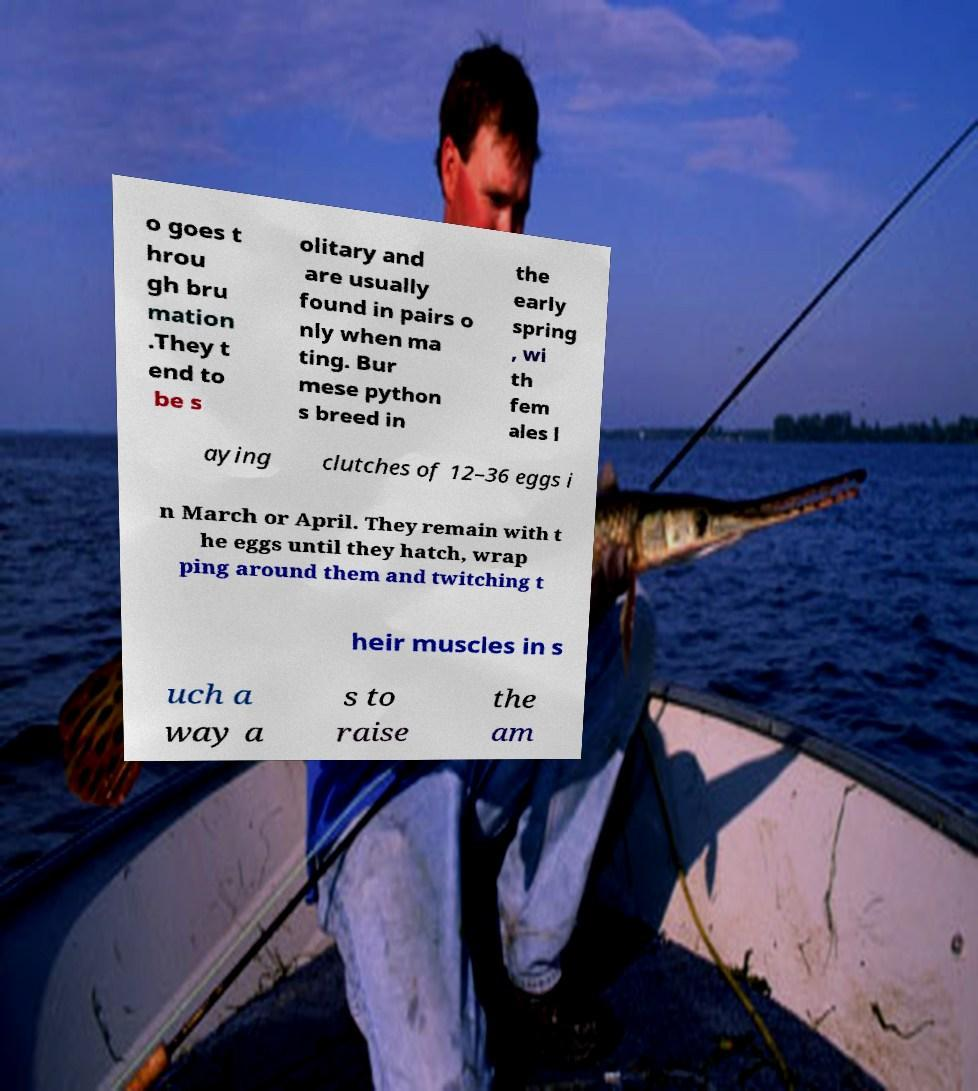Can you accurately transcribe the text from the provided image for me? o goes t hrou gh bru mation .They t end to be s olitary and are usually found in pairs o nly when ma ting. Bur mese python s breed in the early spring , wi th fem ales l aying clutches of 12–36 eggs i n March or April. They remain with t he eggs until they hatch, wrap ping around them and twitching t heir muscles in s uch a way a s to raise the am 